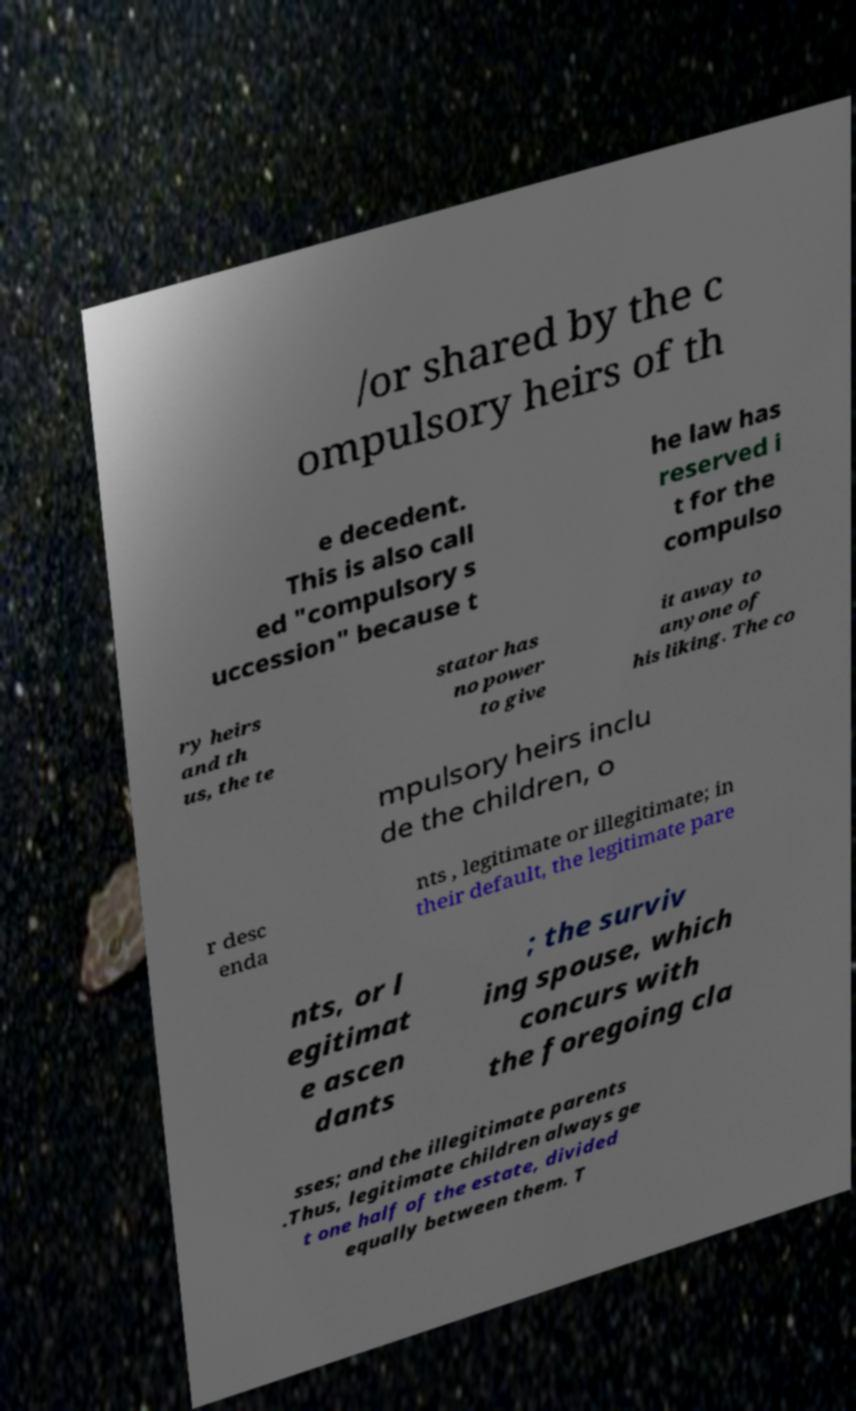There's text embedded in this image that I need extracted. Can you transcribe it verbatim? /or shared by the c ompulsory heirs of th e decedent. This is also call ed "compulsory s uccession" because t he law has reserved i t for the compulso ry heirs and th us, the te stator has no power to give it away to anyone of his liking. The co mpulsory heirs inclu de the children, o r desc enda nts , legitimate or illegitimate; in their default, the legitimate pare nts, or l egitimat e ascen dants ; the surviv ing spouse, which concurs with the foregoing cla sses; and the illegitimate parents .Thus, legitimate children always ge t one half of the estate, divided equally between them. T 